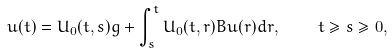Convert formula to latex. <formula><loc_0><loc_0><loc_500><loc_500>u ( t ) = U _ { 0 } ( t , s ) g + \int _ { s } ^ { t } U _ { 0 } ( t , r ) B u ( r ) d r , \quad t \geq s \geq 0 ,</formula> 